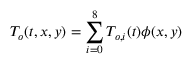<formula> <loc_0><loc_0><loc_500><loc_500>T _ { o } ( t , x , y ) = \sum _ { i = 0 } ^ { 8 } T _ { o , i } ( t ) \phi ( x , y )</formula> 